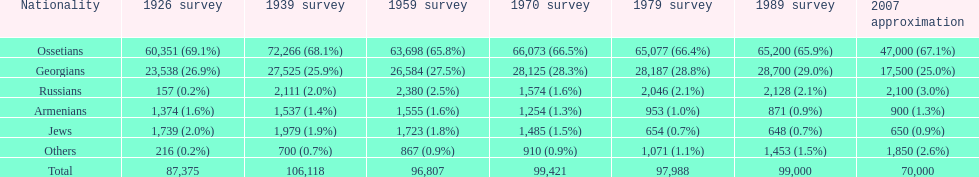Can you give me this table as a dict? {'header': ['Nationality', '1926 survey', '1939 survey', '1959 survey', '1970 survey', '1979 survey', '1989 survey', '2007 approximation'], 'rows': [['Ossetians', '60,351 (69.1%)', '72,266 (68.1%)', '63,698 (65.8%)', '66,073 (66.5%)', '65,077 (66.4%)', '65,200 (65.9%)', '47,000 (67.1%)'], ['Georgians', '23,538 (26.9%)', '27,525 (25.9%)', '26,584 (27.5%)', '28,125 (28.3%)', '28,187 (28.8%)', '28,700 (29.0%)', '17,500 (25.0%)'], ['Russians', '157 (0.2%)', '2,111 (2.0%)', '2,380 (2.5%)', '1,574 (1.6%)', '2,046 (2.1%)', '2,128 (2.1%)', '2,100 (3.0%)'], ['Armenians', '1,374 (1.6%)', '1,537 (1.4%)', '1,555 (1.6%)', '1,254 (1.3%)', '953 (1.0%)', '871 (0.9%)', '900 (1.3%)'], ['Jews', '1,739 (2.0%)', '1,979 (1.9%)', '1,723 (1.8%)', '1,485 (1.5%)', '654 (0.7%)', '648 (0.7%)', '650 (0.9%)'], ['Others', '216 (0.2%)', '700 (0.7%)', '867 (0.9%)', '910 (0.9%)', '1,071 (1.1%)', '1,453 (1.5%)', '1,850 (2.6%)'], ['Total', '87,375', '106,118', '96,807', '99,421', '97,988', '99,000', '70,000']]} What was the first census that saw a russian population of over 2,000? 1939 census. 